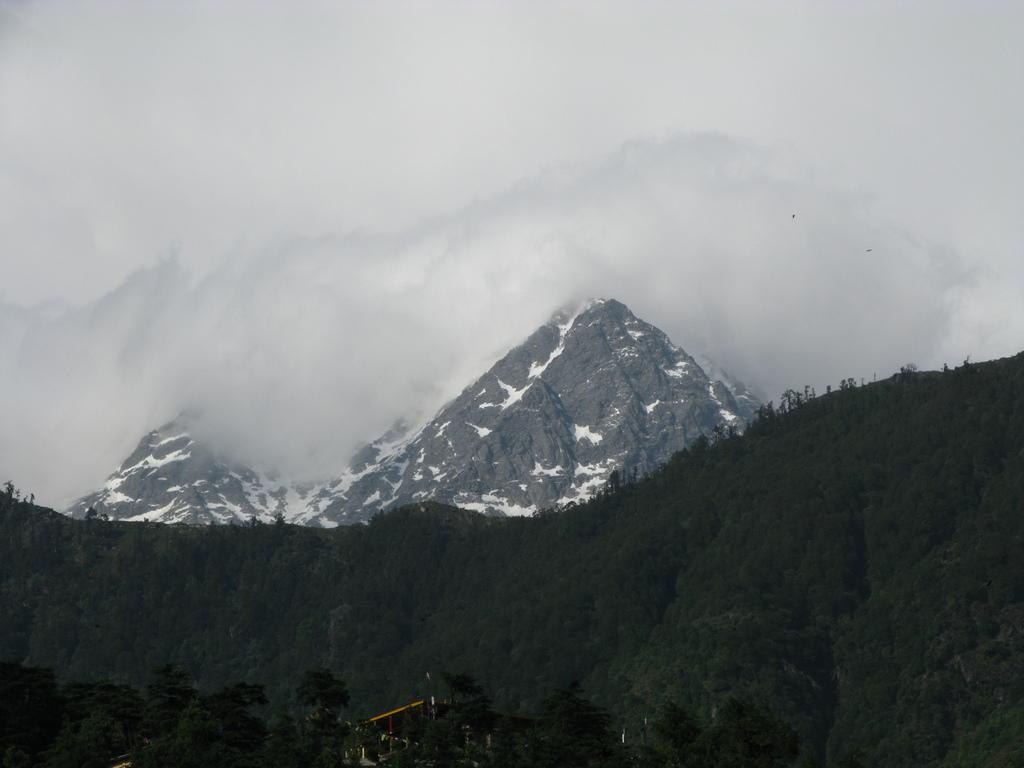What type of vegetation can be seen in the image? There are trees in the image. What geographical features are present in the image? There are hills and snowy mountains in the image. What atmospheric condition is visible in the image? There is fog in the image. Can you tell me what time it is according to the clock in the image? There is no clock present in the image. What type of cabbage is growing on the hills in the image? There is no cabbage present in the image; the hills are covered in snow and vegetation is not visible. 